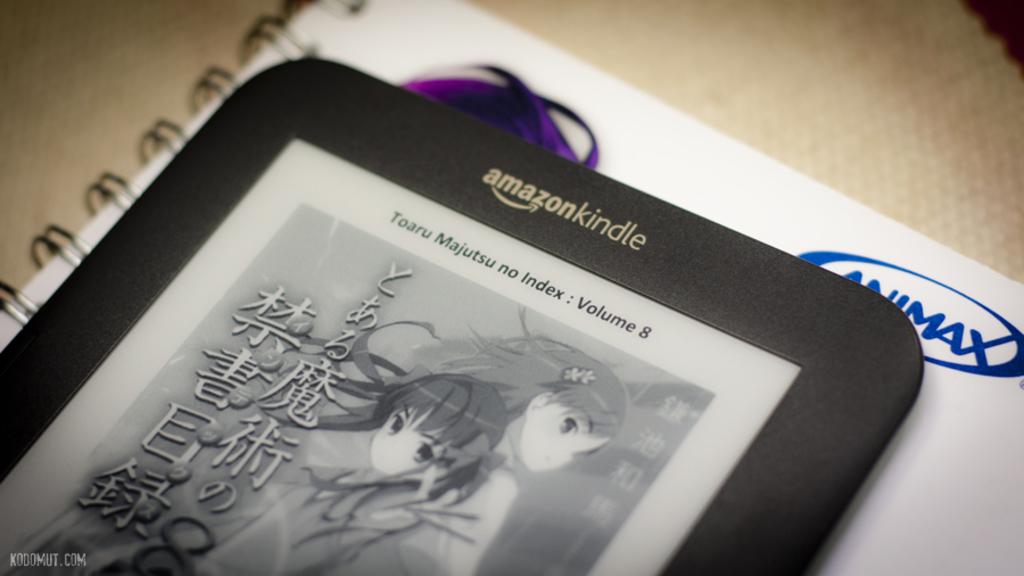What brand of table it pictured?
Your response must be concise. Amazon kindle. What volume is the image on the tablet?
Your answer should be compact. 8. 